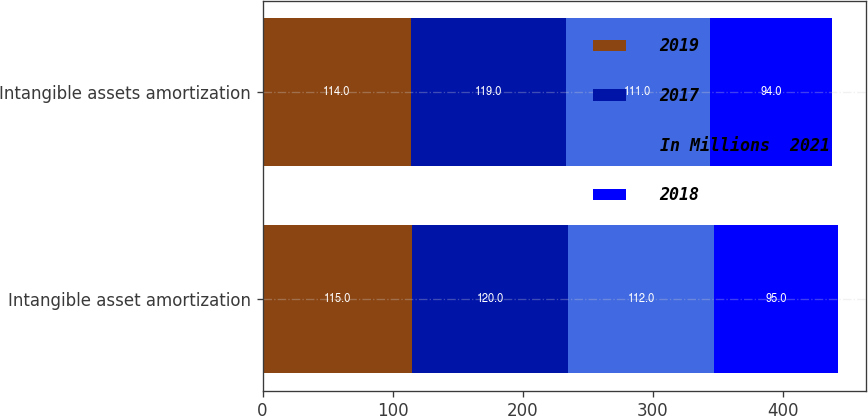<chart> <loc_0><loc_0><loc_500><loc_500><stacked_bar_chart><ecel><fcel>Intangible asset amortization<fcel>Intangible assets amortization<nl><fcel>2019<fcel>115<fcel>114<nl><fcel>2017<fcel>120<fcel>119<nl><fcel>In Millions  2021<fcel>112<fcel>111<nl><fcel>2018<fcel>95<fcel>94<nl></chart> 